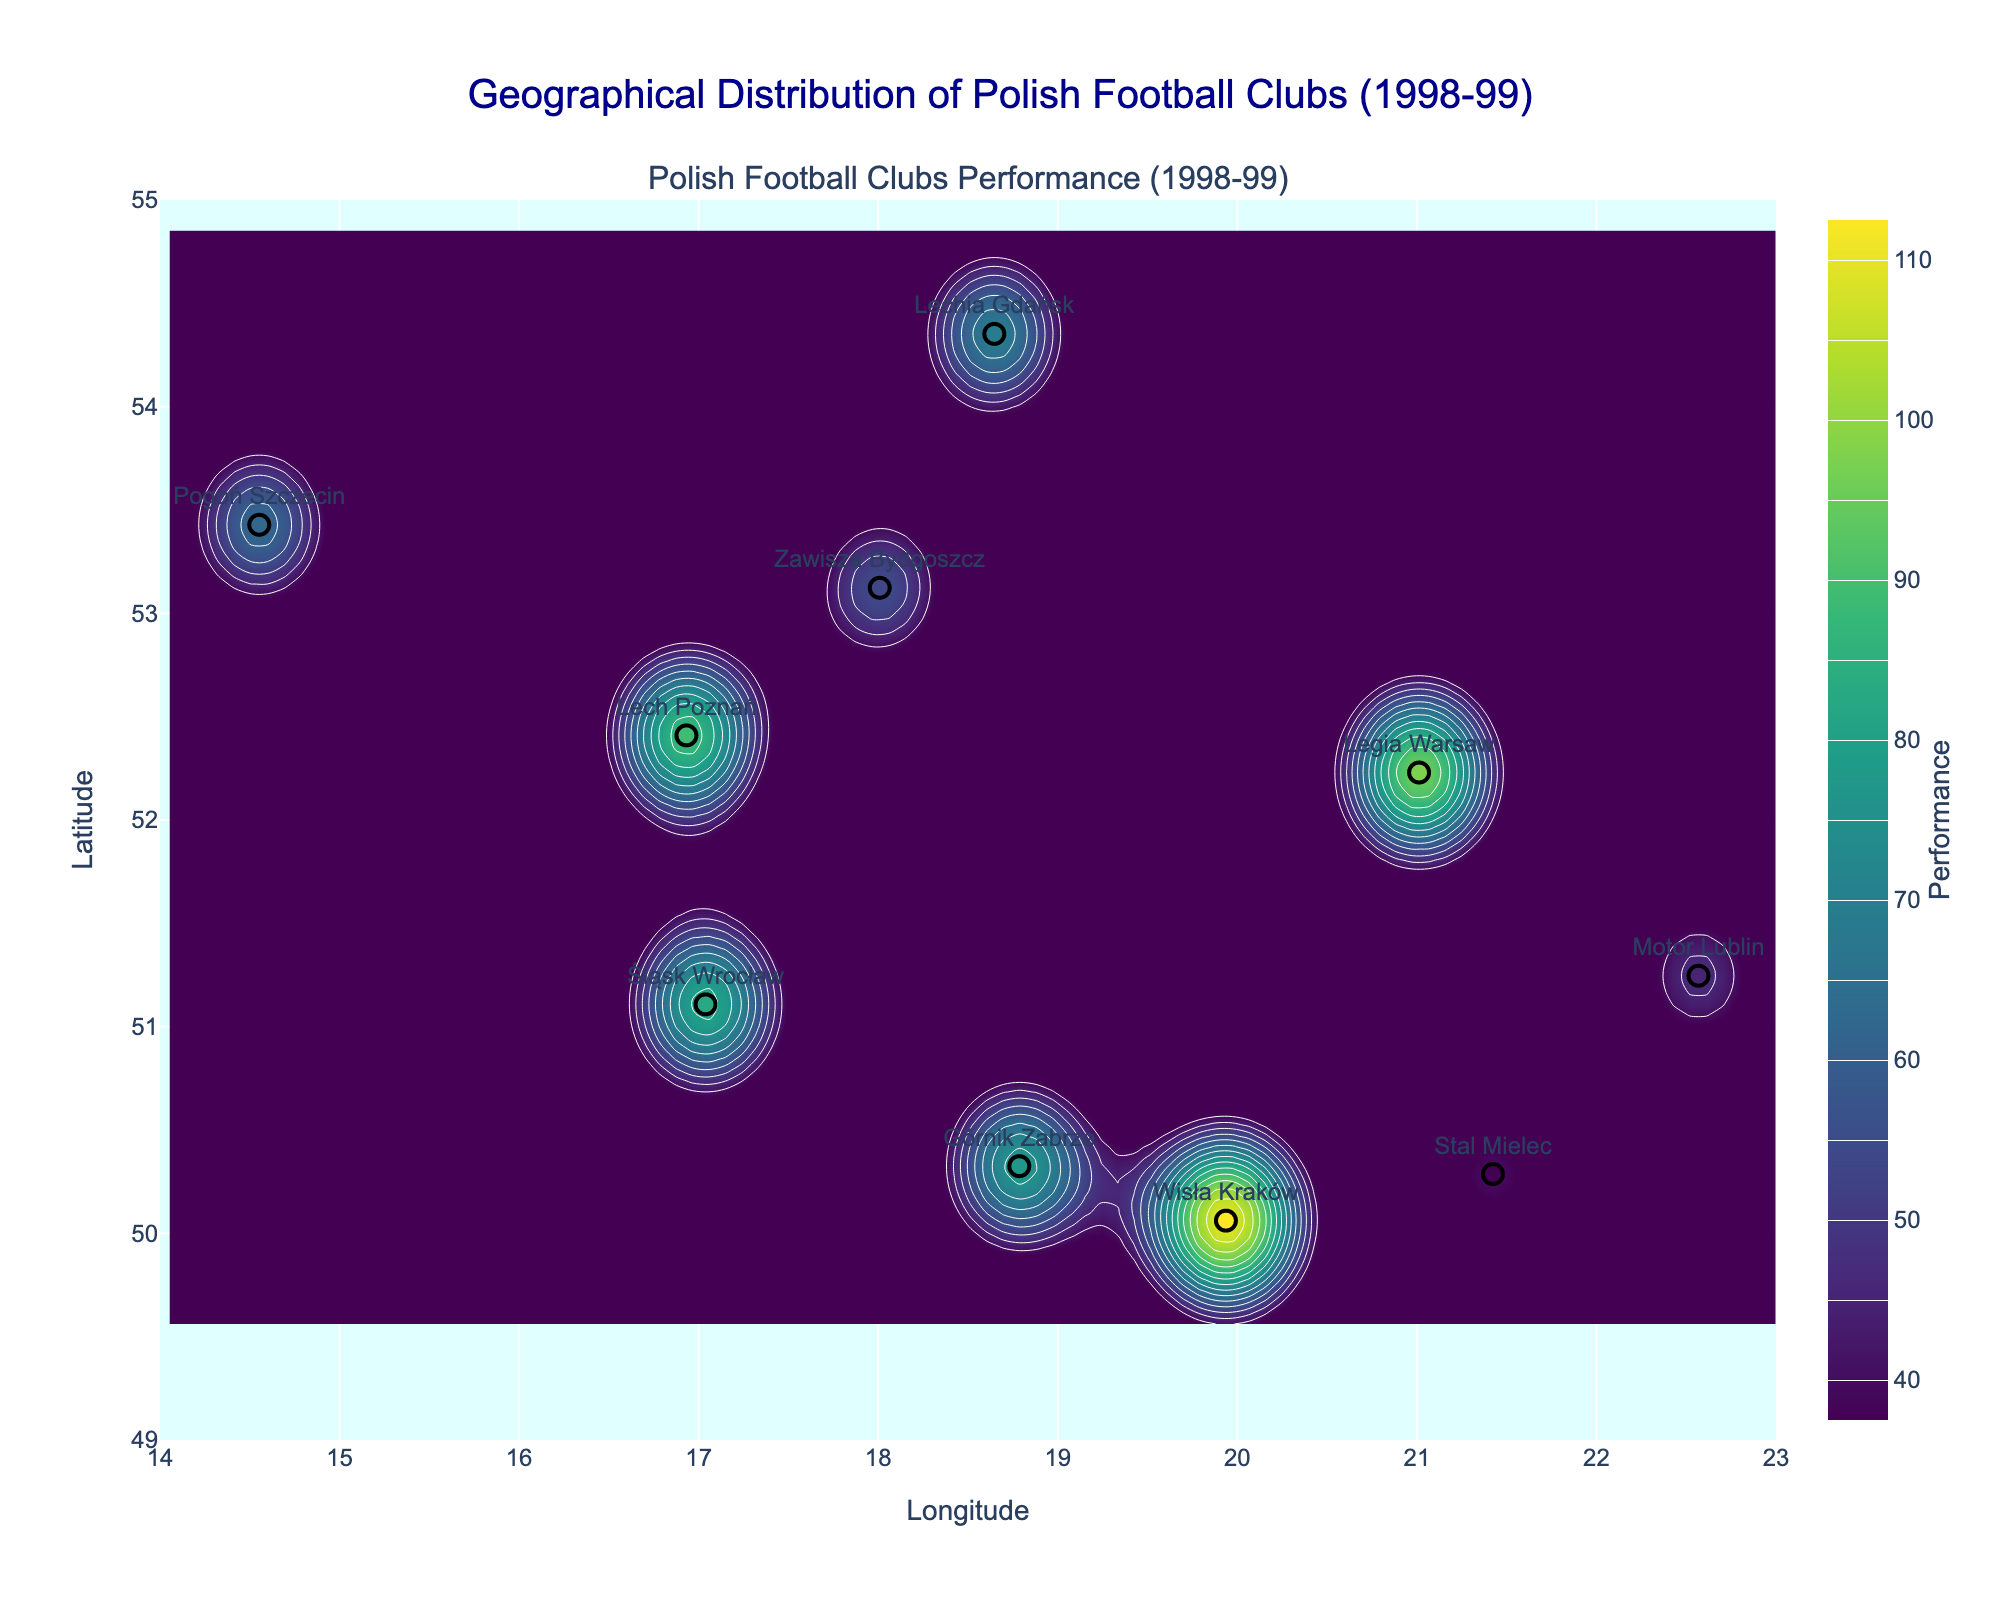What is the performance level of Legia Warsaw? Look at the data points plotted on the map. The performance level of Legia Warsaw is indicated by the color and also by the text if you hover over it.
Answer: 96 Which football club is the southernmost on the map? The club's position can be determined by its latitude. The southernmost latitude is the lowest value shown on the y-axis (latitude).
Answer: Stal Mielec What is the highest performance value shown on the contour plot? By observing the contour plot and the associated color bar, locate the highest performance value represented.
Answer: 110 Which club is located closest to the western edge of Poland? Look at clubs' longitude values to determine which is closest to the minimum longitude value.
Answer: Pogoń Szczecin How many clubs have a performance level above 80? Check the performance values for each club to see how many are above the threshold of 80.
Answer: 4 How does the performance of Śląsk Wrocław compare to Górnik Zabrze? Compare the performance values of Śląsk Wrocław and Górnik Zabrze.
Answer: Śląsk Wrocław performed better than Górnik Zabrze Which region's football club has the highest performance? Observe the performance values and regions to determine which one is highest.
Answer: Lesser Poland (Wisła Kraków) What range of performance values do the contour lines represent? Examine the color bar and legend associated with the contour plot to find the start and end values of the range.
Answer: 40 - 110 What is the performance level of the club located furthest east? Identify the club with the highest longitude and look at its performance value.
Answer: Motor Lublin, 47 